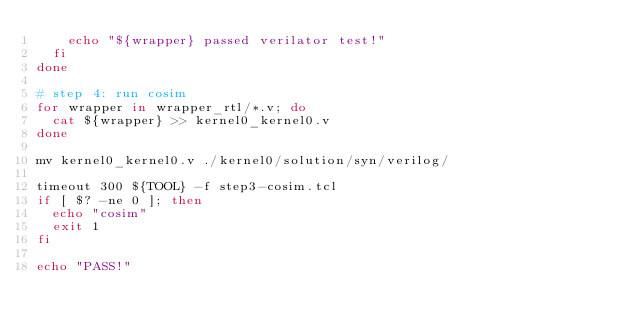<code> <loc_0><loc_0><loc_500><loc_500><_Bash_>    echo "${wrapper} passed verilator test!"
  fi
done

# step 4: run cosim
for wrapper in wrapper_rtl/*.v; do
  cat ${wrapper} >> kernel0_kernel0.v
done

mv kernel0_kernel0.v ./kernel0/solution/syn/verilog/

timeout 300 ${TOOL} -f step3-cosim.tcl
if [ $? -ne 0 ]; then
  echo "cosim"
  exit 1
fi

echo "PASS!"
</code> 